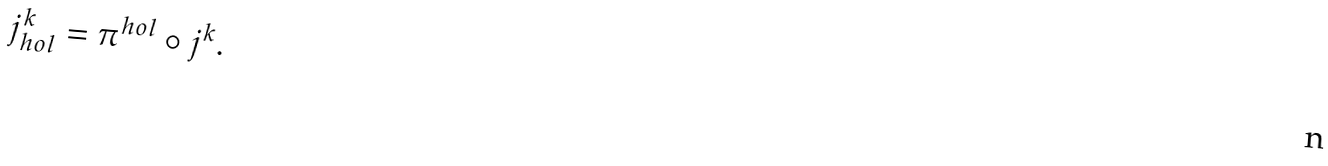Convert formula to latex. <formula><loc_0><loc_0><loc_500><loc_500>j _ { h o l } ^ { k } = \pi ^ { h o l } \circ j ^ { k } .</formula> 